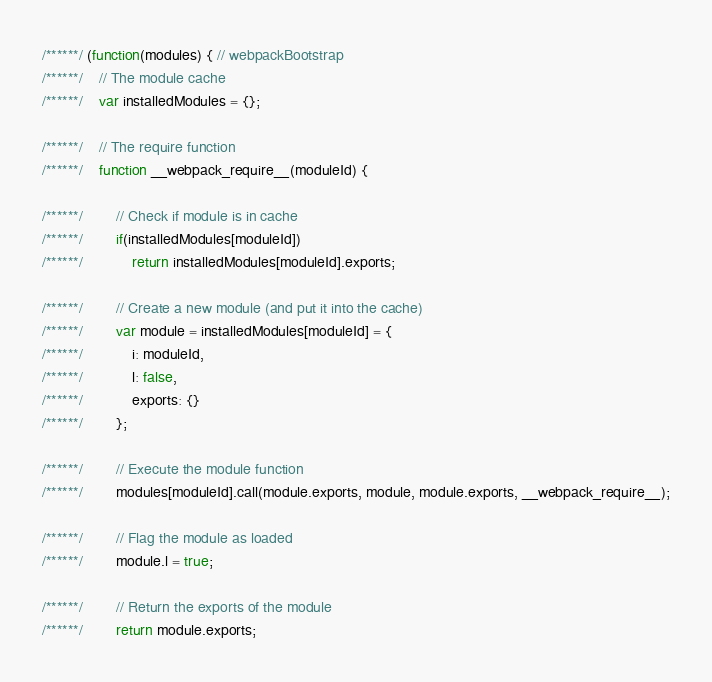Convert code to text. <code><loc_0><loc_0><loc_500><loc_500><_JavaScript_>/******/ (function(modules) { // webpackBootstrap
/******/ 	// The module cache
/******/ 	var installedModules = {};

/******/ 	// The require function
/******/ 	function __webpack_require__(moduleId) {

/******/ 		// Check if module is in cache
/******/ 		if(installedModules[moduleId])
/******/ 			return installedModules[moduleId].exports;

/******/ 		// Create a new module (and put it into the cache)
/******/ 		var module = installedModules[moduleId] = {
/******/ 			i: moduleId,
/******/ 			l: false,
/******/ 			exports: {}
/******/ 		};

/******/ 		// Execute the module function
/******/ 		modules[moduleId].call(module.exports, module, module.exports, __webpack_require__);

/******/ 		// Flag the module as loaded
/******/ 		module.l = true;

/******/ 		// Return the exports of the module
/******/ 		return module.exports;</code> 